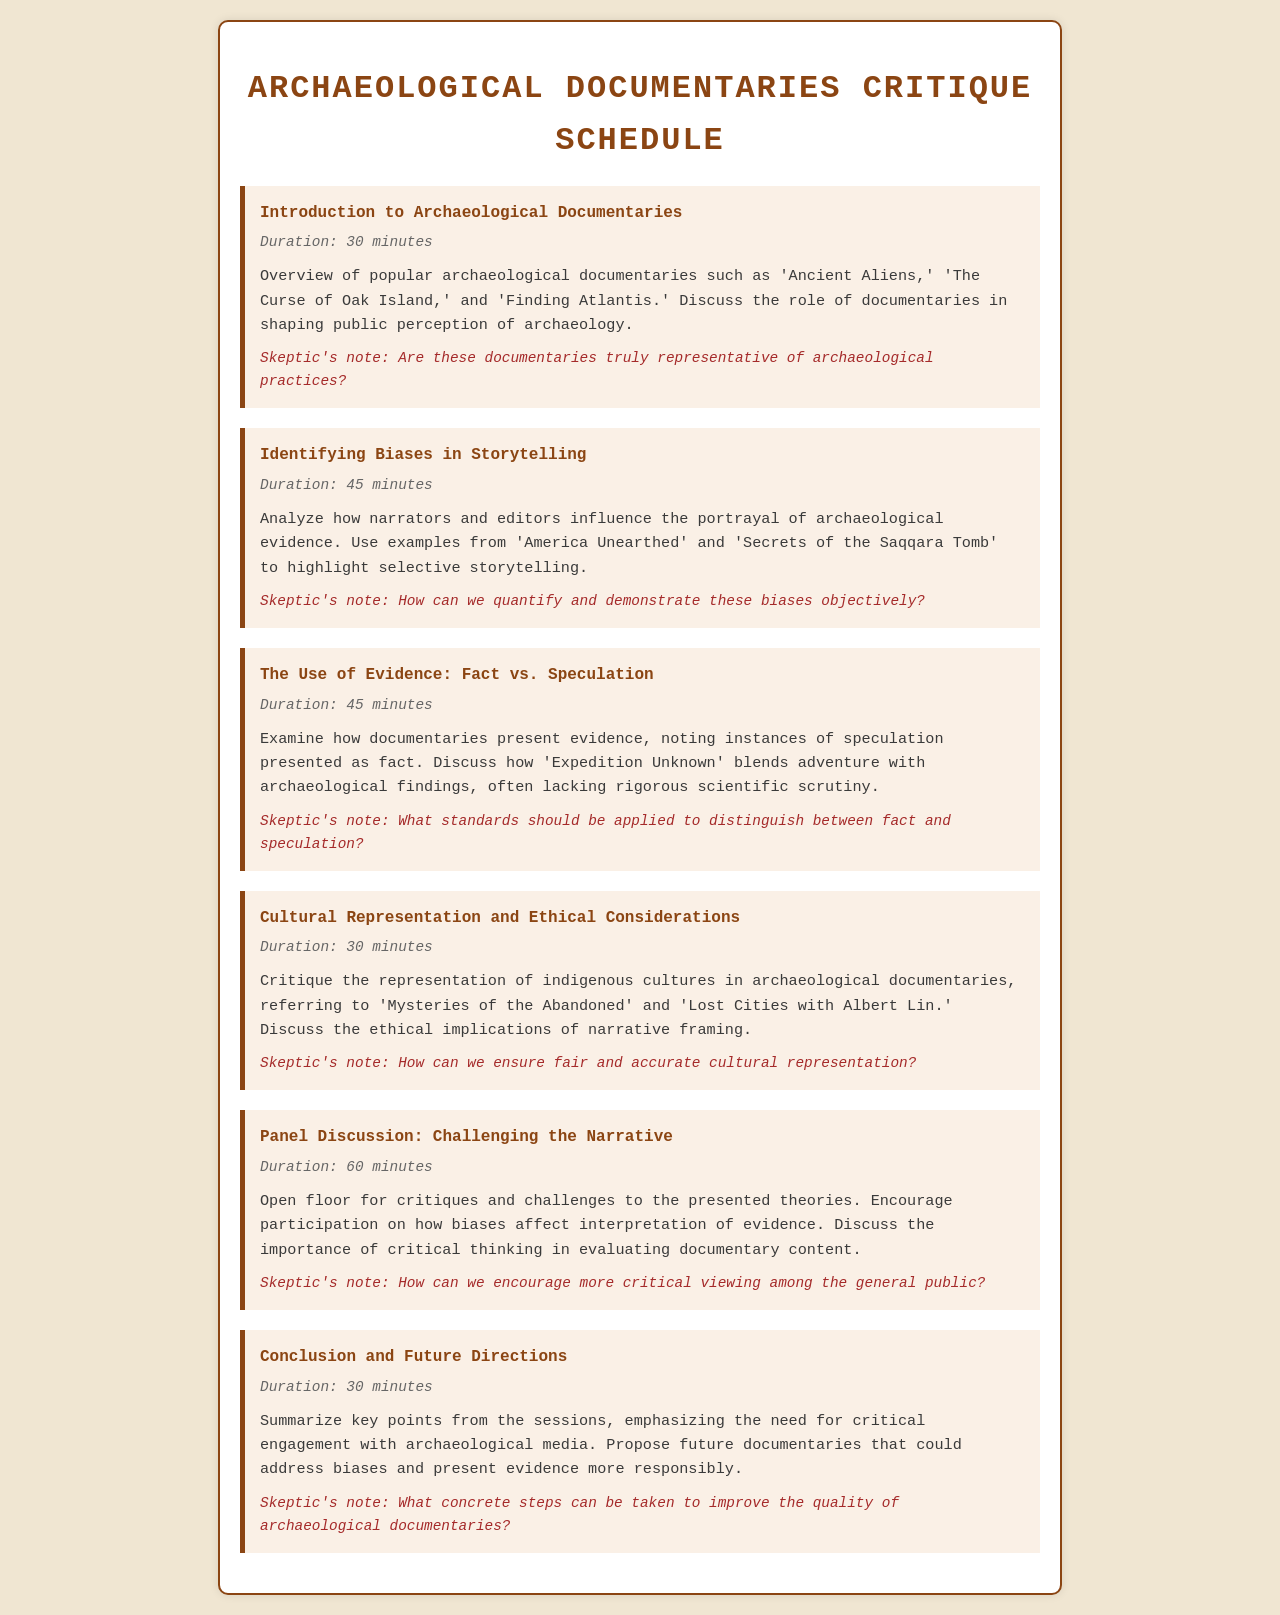What is the title of the document? The title of the document is presented in the header section, indicating the subject matter it covers.
Answer: Archaeological Documentaries Critique Schedule How long is the session on cultural representation? The duration is specified in the content area of the session, providing a clear length for that discussion.
Answer: 30 minutes Which documentary is referenced in the session titled "Identifying Biases in Storytelling"? This documentary is mentioned as an example to illustrate biases in narrative framing within the session content.
Answer: America Unearthed What is a key focus in the panel discussion session? The content describes the aim of the session, highlighting the aspect of participant engagement in critiques.
Answer: Challenging the narrative What is the duration of the introduction session? This duration is clearly listed alongside the session title, indicating how much time is allocated.
Answer: 30 minutes In which session are ethical implications discussed? The content outlines this session's focus, making it clear what themes will be examined concerning ethics.
Answer: Cultural Representation and Ethical Considerations What phrase describes the skeptic's note regarding biases? The note offers a critical perspective on how to assess and explain the identified biases in documentaries.
Answer: How can we quantify and demonstrate these biases objectively? What session emphasizes the need for critical engagement with archaeological media? The content has summarized points that call for more thoughtful approaches when consuming media based on archaeology.
Answer: Conclusion and Future Directions 